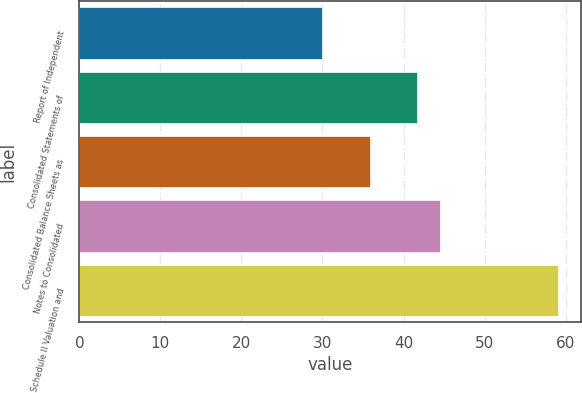Convert chart to OTSL. <chart><loc_0><loc_0><loc_500><loc_500><bar_chart><fcel>Report of Independent<fcel>Consolidated Statements of<fcel>Consolidated Balance Sheets as<fcel>Notes to Consolidated<fcel>Schedule II Valuation and<nl><fcel>30<fcel>41.6<fcel>35.8<fcel>44.5<fcel>59<nl></chart> 